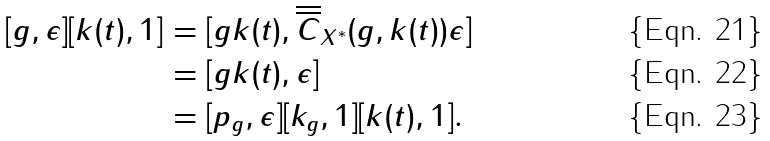<formula> <loc_0><loc_0><loc_500><loc_500>[ g , \epsilon ] [ k ( t ) , 1 ] & = [ g k ( t ) , \overline { \overline { C } } _ { X ^ { \ast } } ( g , k ( t ) ) \epsilon ] \\ & = [ g k ( t ) , \epsilon ] \\ & = [ p _ { g } , \epsilon ] [ k _ { g } , 1 ] [ k ( t ) , 1 ] .</formula> 